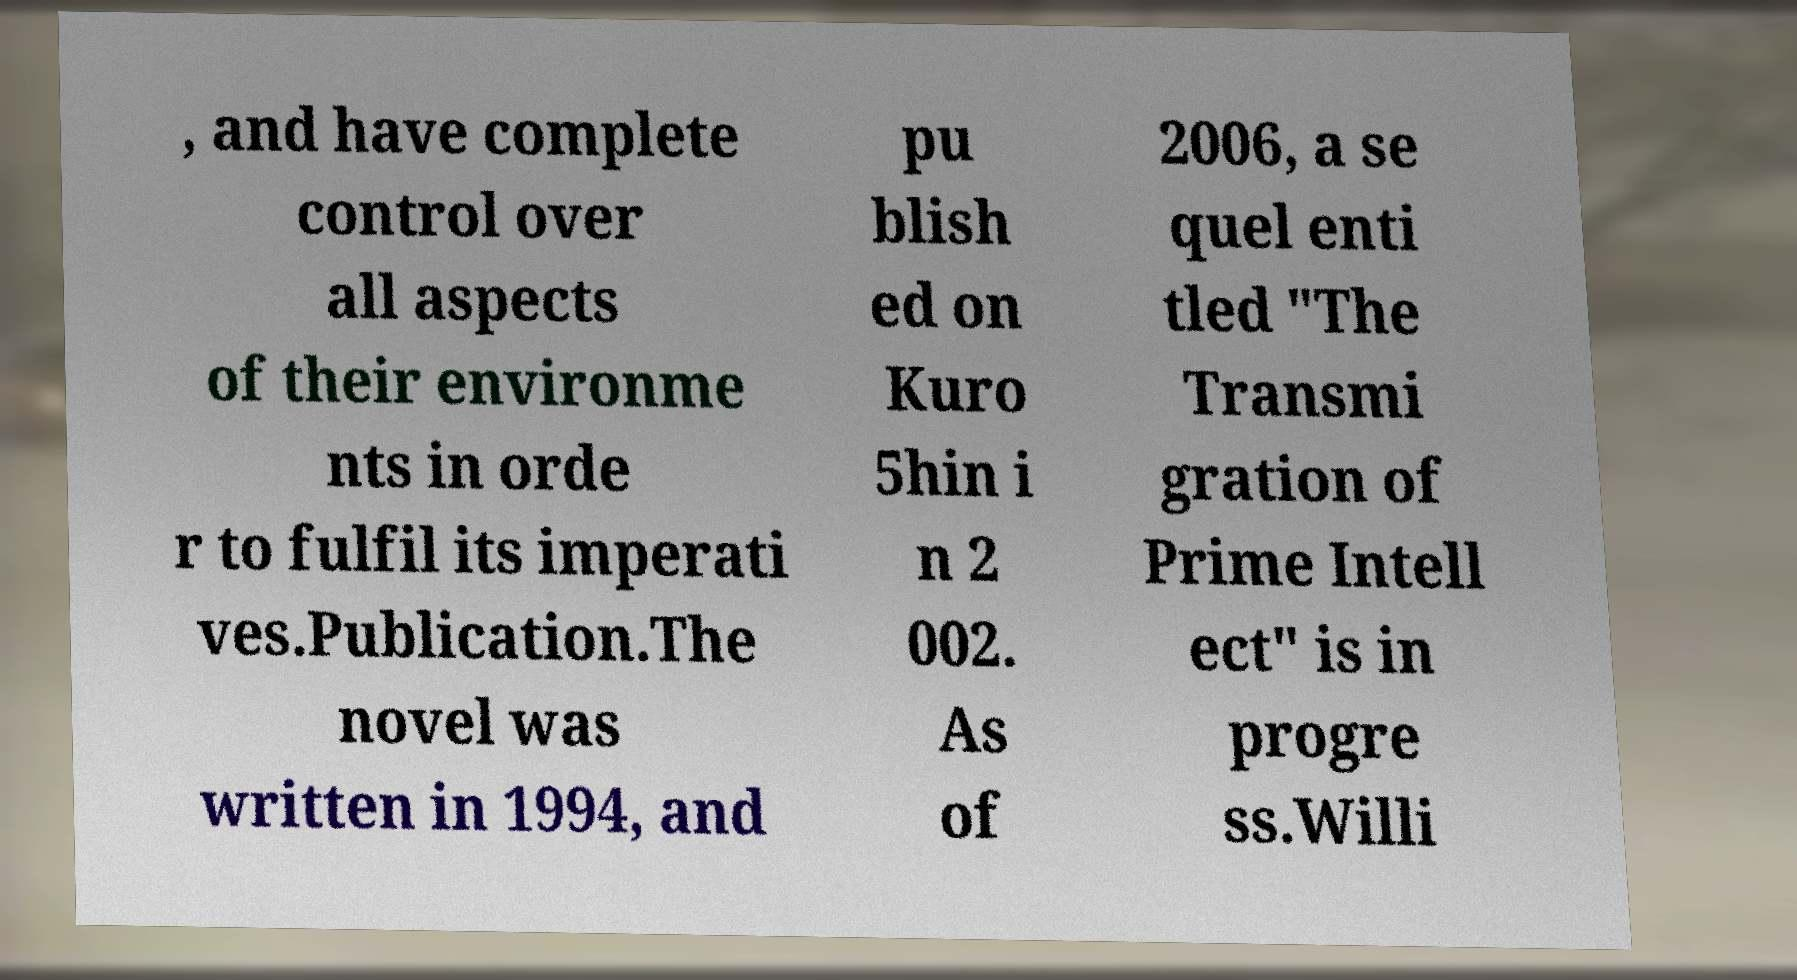There's text embedded in this image that I need extracted. Can you transcribe it verbatim? , and have complete control over all aspects of their environme nts in orde r to fulfil its imperati ves.Publication.The novel was written in 1994, and pu blish ed on Kuro 5hin i n 2 002. As of 2006, a se quel enti tled "The Transmi gration of Prime Intell ect" is in progre ss.Willi 